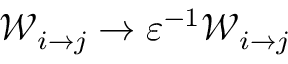Convert formula to latex. <formula><loc_0><loc_0><loc_500><loc_500>\mathcal { W } _ { i \to j } \to \varepsilon ^ { - 1 } \mathcal { W } _ { i \to j }</formula> 